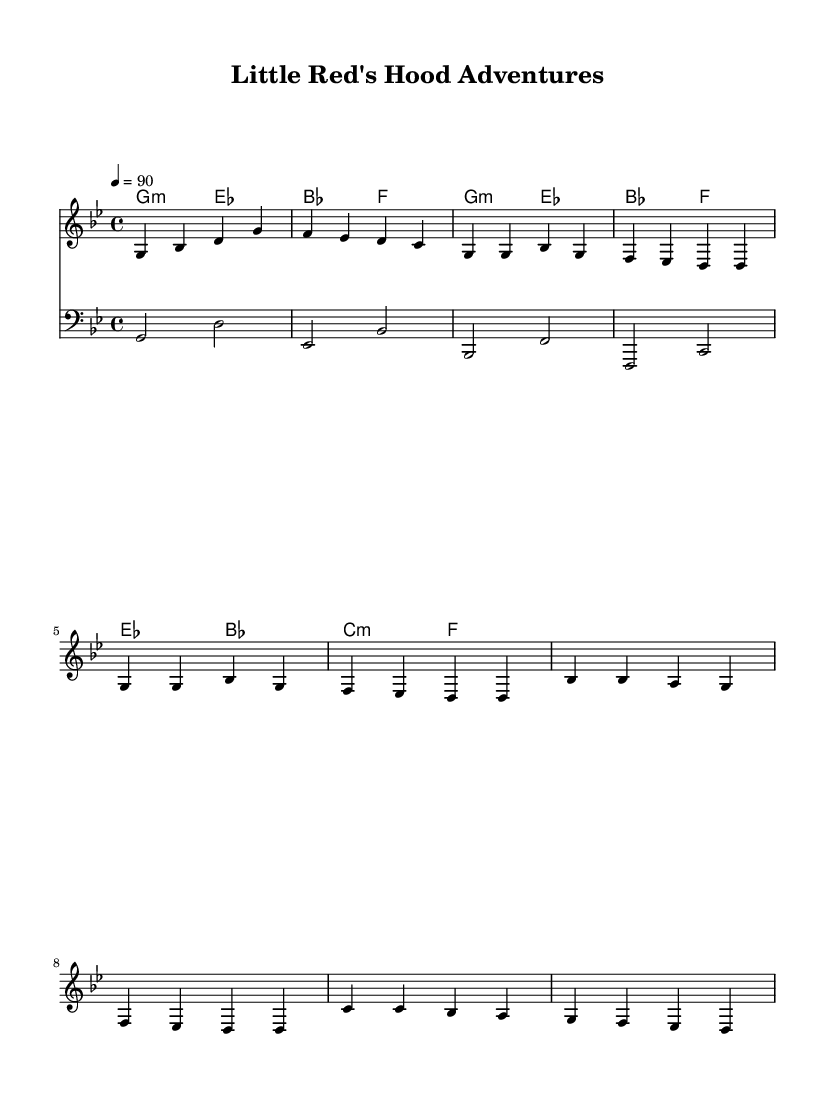What is the key signature of this music? The key signature is G minor, which has two flats: B-flat and E-flat. This is determined by observing the key signature at the beginning of the staff where two flat symbols are placed.
Answer: G minor What is the time signature of this music? The time signature is 4/4, indicating four beats per measure and a quarter note receives one beat. This is noted at the beginning of the score following the key signature.
Answer: 4/4 What is the tempo marking for this piece? The tempo marking is 90 beats per minute, as indicated by "4 = 90" at the start of the score, which tells how many beats occur in one minute of playing.
Answer: 90 How many measures are in the melody section provided? There are 8 measures in the melody section, which can be counted by observing the vertical lines (bar lines) that separate each measure in the sheet music.
Answer: 8 What is the style or genre of this piece? The style or genre of this piece is Rap, suggested by the title "Little Red's Hood Adventures," which indicates a modern twist on a classic fairy tale likely delivered in a rhythmic spoken manner common to rap music.
Answer: Rap What is the primary chord used in the introduction? The primary chord used in the introduction is G minor, which is indicated in the chord progression at the start of the harmonies section.
Answer: G minor What is the last note of the chorus section? The last note of the chorus section is D, which is the last note in the melody line for the chorus as shown at the end of the chorus measures.
Answer: D 